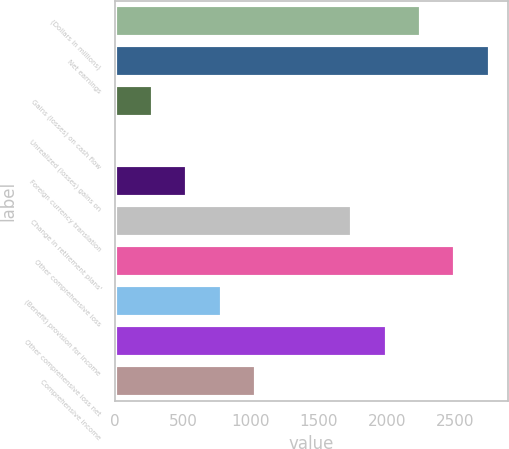Convert chart to OTSL. <chart><loc_0><loc_0><loc_500><loc_500><bar_chart><fcel>(Dollars in millions)<fcel>Net earnings<fcel>Gains (losses) on cash flow<fcel>Unrealized (losses) gains on<fcel>Foreign currency translation<fcel>Change in retirement plans'<fcel>Other comprehensive loss<fcel>(Benefit) provision for income<fcel>Other comprehensive loss net<fcel>Comprehensive income<nl><fcel>2249.6<fcel>2754.2<fcel>279<fcel>10<fcel>531.3<fcel>1745<fcel>2501.9<fcel>783.6<fcel>1997.3<fcel>1035.9<nl></chart> 